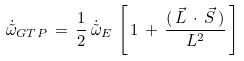Convert formula to latex. <formula><loc_0><loc_0><loc_500><loc_500>\dot { \tilde { \omega } } _ { G T P } \, = \, \frac { 1 } { 2 } \, \dot { \tilde { \omega } } _ { E } \, \left [ \, 1 \, + \, \frac { ( \, \vec { L } \, \cdot \, \vec { S } \, ) } { L ^ { 2 } } \, \right ]</formula> 